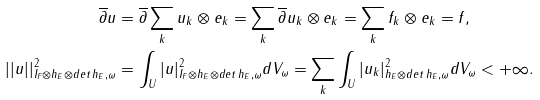<formula> <loc_0><loc_0><loc_500><loc_500>\overline { \partial } u & = \overline { \partial } \sum _ { k } u _ { k } \otimes e _ { k } = \sum _ { k } \overline { \partial } u _ { k } \otimes e _ { k } = \sum _ { k } f _ { k } \otimes e _ { k } = f , \\ | | u | | ^ { 2 } _ { I _ { F } \otimes h _ { E } \otimes d e t \, h _ { E } , \omega } & = \int _ { U } | u | ^ { 2 } _ { I _ { F } \otimes h _ { E } \otimes d e t \, h _ { E } , \omega } d V _ { \omega } = \sum _ { k } \int _ { U } | u _ { k } | ^ { 2 } _ { h _ { E } \otimes d e t \, h _ { E } , \omega } d V _ { \omega } < + \infty .</formula> 